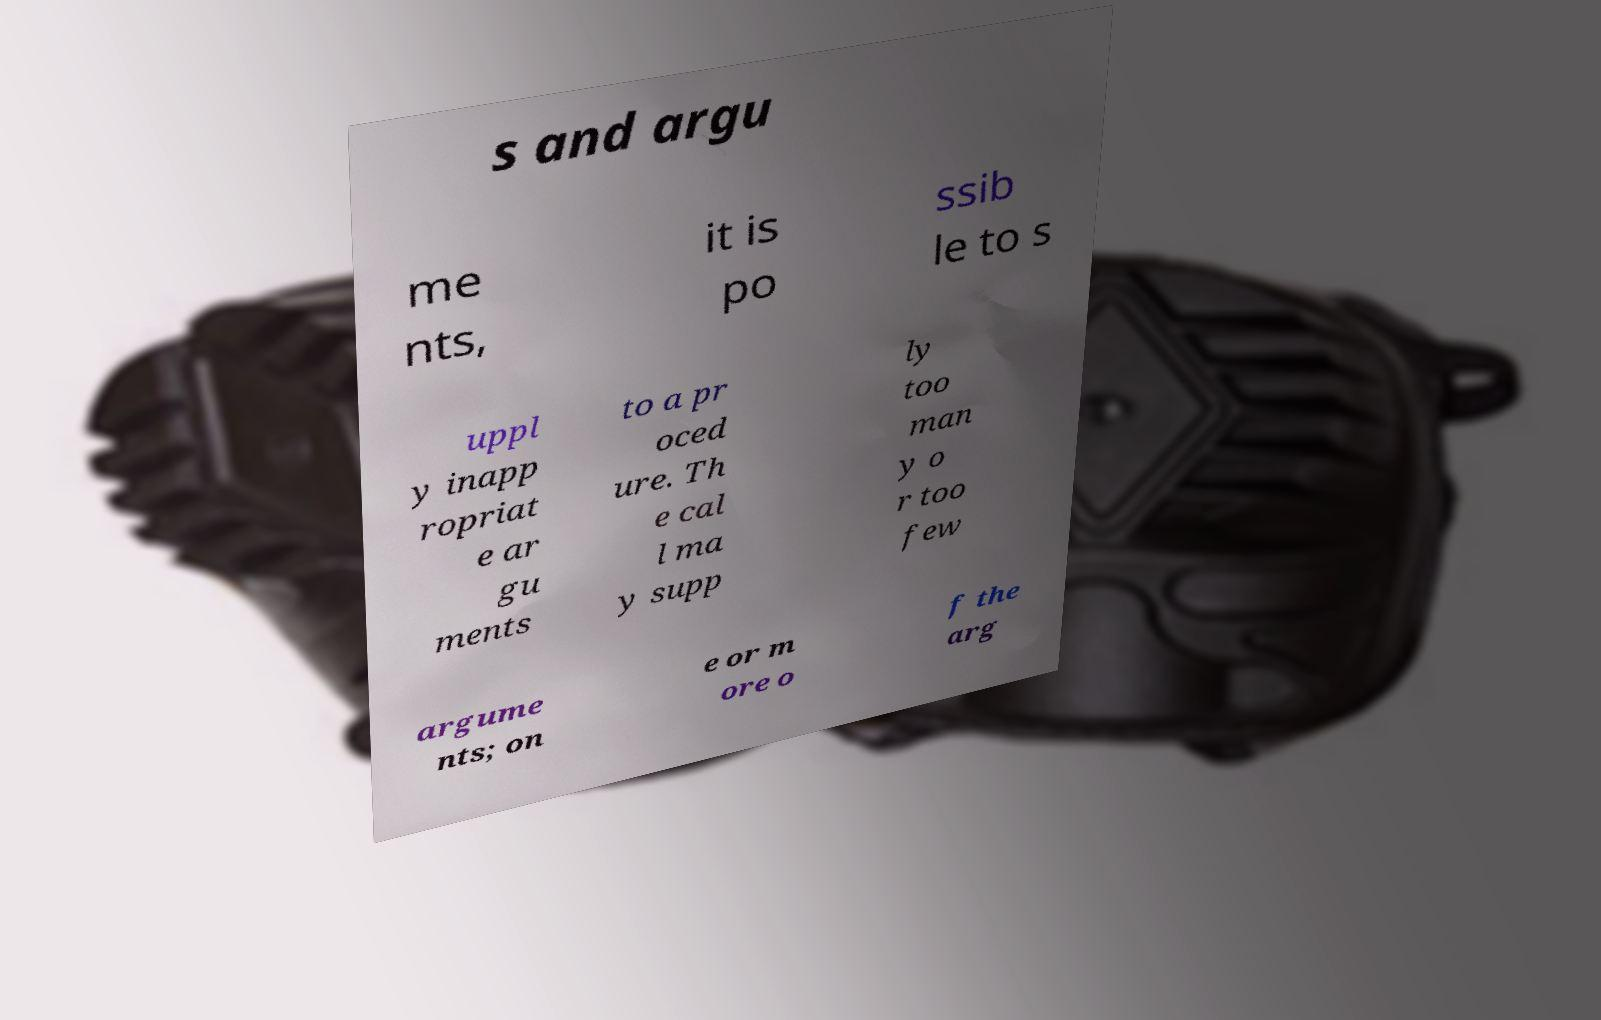Could you assist in decoding the text presented in this image and type it out clearly? s and argu me nts, it is po ssib le to s uppl y inapp ropriat e ar gu ments to a pr oced ure. Th e cal l ma y supp ly too man y o r too few argume nts; on e or m ore o f the arg 